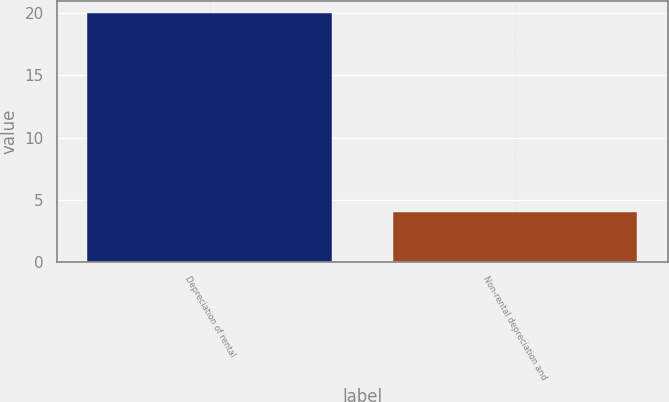Convert chart to OTSL. <chart><loc_0><loc_0><loc_500><loc_500><bar_chart><fcel>Depreciation of rental<fcel>Non-rental depreciation and<nl><fcel>20<fcel>4<nl></chart> 